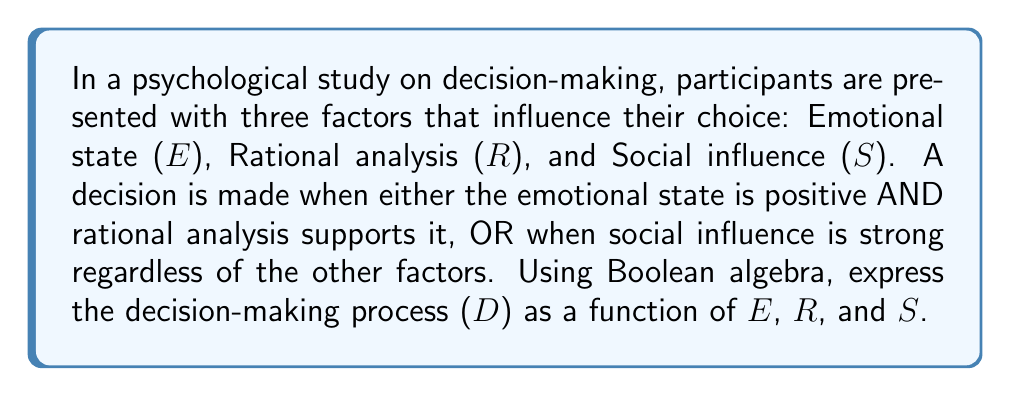Help me with this question. Let's approach this step-by-step using Boolean algebra:

1) First, we need to identify the conditions for a decision to be made:
   - Condition 1: Emotional state is positive (E) AND rational analysis supports it (R)
   - Condition 2: Social influence is strong (S)

2) We can express Condition 1 using the AND operator (•):
   $E • R$

3) Condition 2 is simply S

4) The overall decision is made if either Condition 1 OR Condition 2 is true. We use the OR operator (+) to combine these:
   $D = (E • R) + S$

5) This expression can be further simplified using the distributive law of Boolean algebra:
   $D = (E • R) + (S • 1)$
   $D = (E • R) + (S • (E + E'))$ (where E' is the complement of E)
   $D = (E • R) + (S • E) + (S • E')$

6) The final expression represents the decision-making process as a function of E, R, and S:
   $D = (E • R) + (S • E) + (S • E')$

This Boolean expression captures the complexity of the decision-making process, showing how emotional state, rational analysis, and social influence interact to produce a decision.
Answer: $D = (E • R) + S$ 